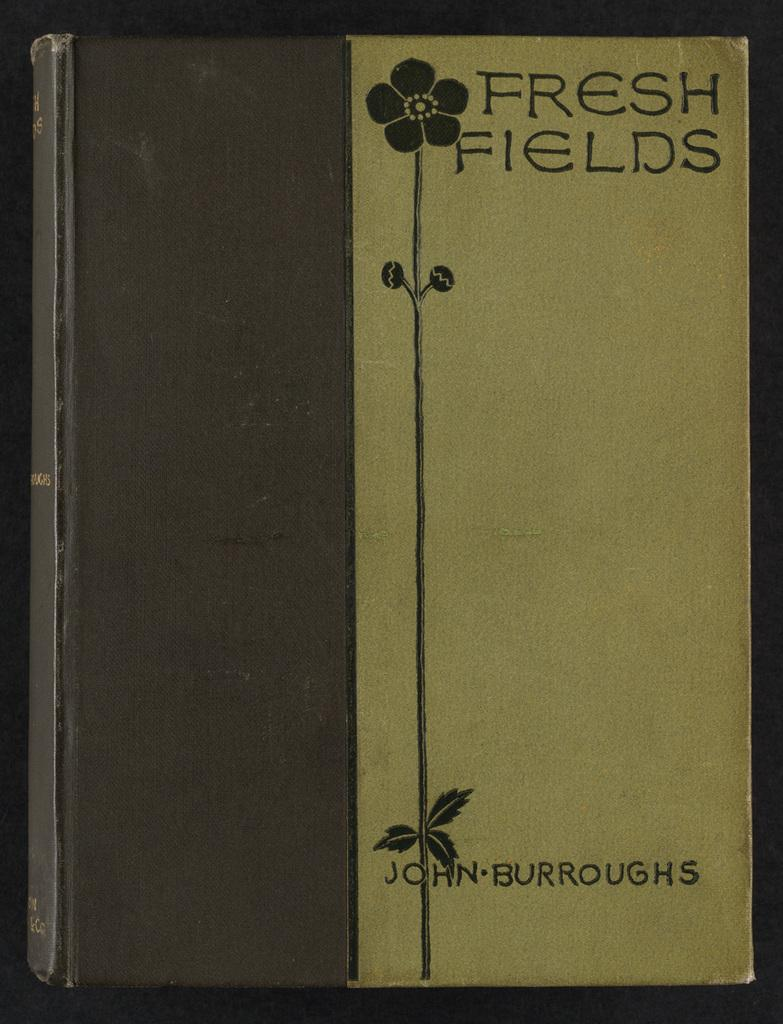<image>
Write a terse but informative summary of the picture. A duo tone hard bound book called Fresh Fields by Joh and Burroughs with a flower and stem spanning the length of the cover. 